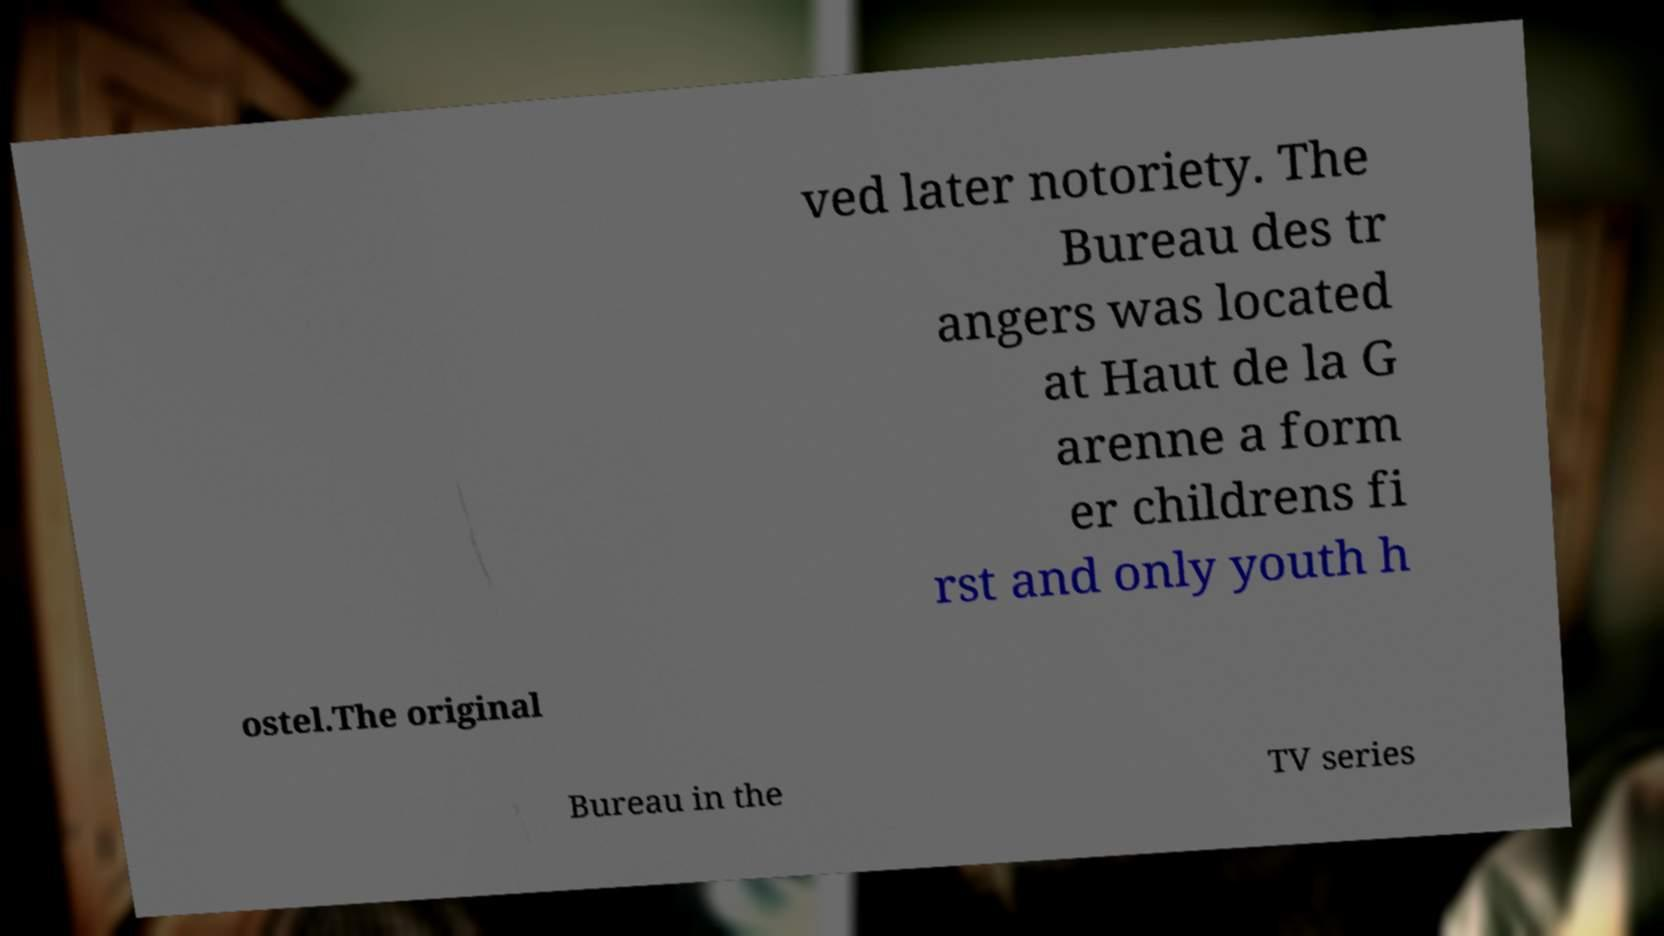Could you assist in decoding the text presented in this image and type it out clearly? ved later notoriety. The Bureau des tr angers was located at Haut de la G arenne a form er childrens fi rst and only youth h ostel.The original Bureau in the TV series 